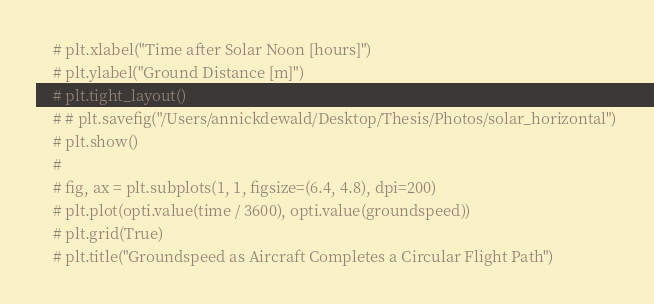Convert code to text. <code><loc_0><loc_0><loc_500><loc_500><_Python_>    # plt.xlabel("Time after Solar Noon [hours]")
    # plt.ylabel("Ground Distance [m]")
    # plt.tight_layout()
    # # plt.savefig("/Users/annickdewald/Desktop/Thesis/Photos/solar_horizontal")
    # plt.show()
    #
    # fig, ax = plt.subplots(1, 1, figsize=(6.4, 4.8), dpi=200)
    # plt.plot(opti.value(time / 3600), opti.value(groundspeed))
    # plt.grid(True)
    # plt.title("Groundspeed as Aircraft Completes a Circular Flight Path")</code> 